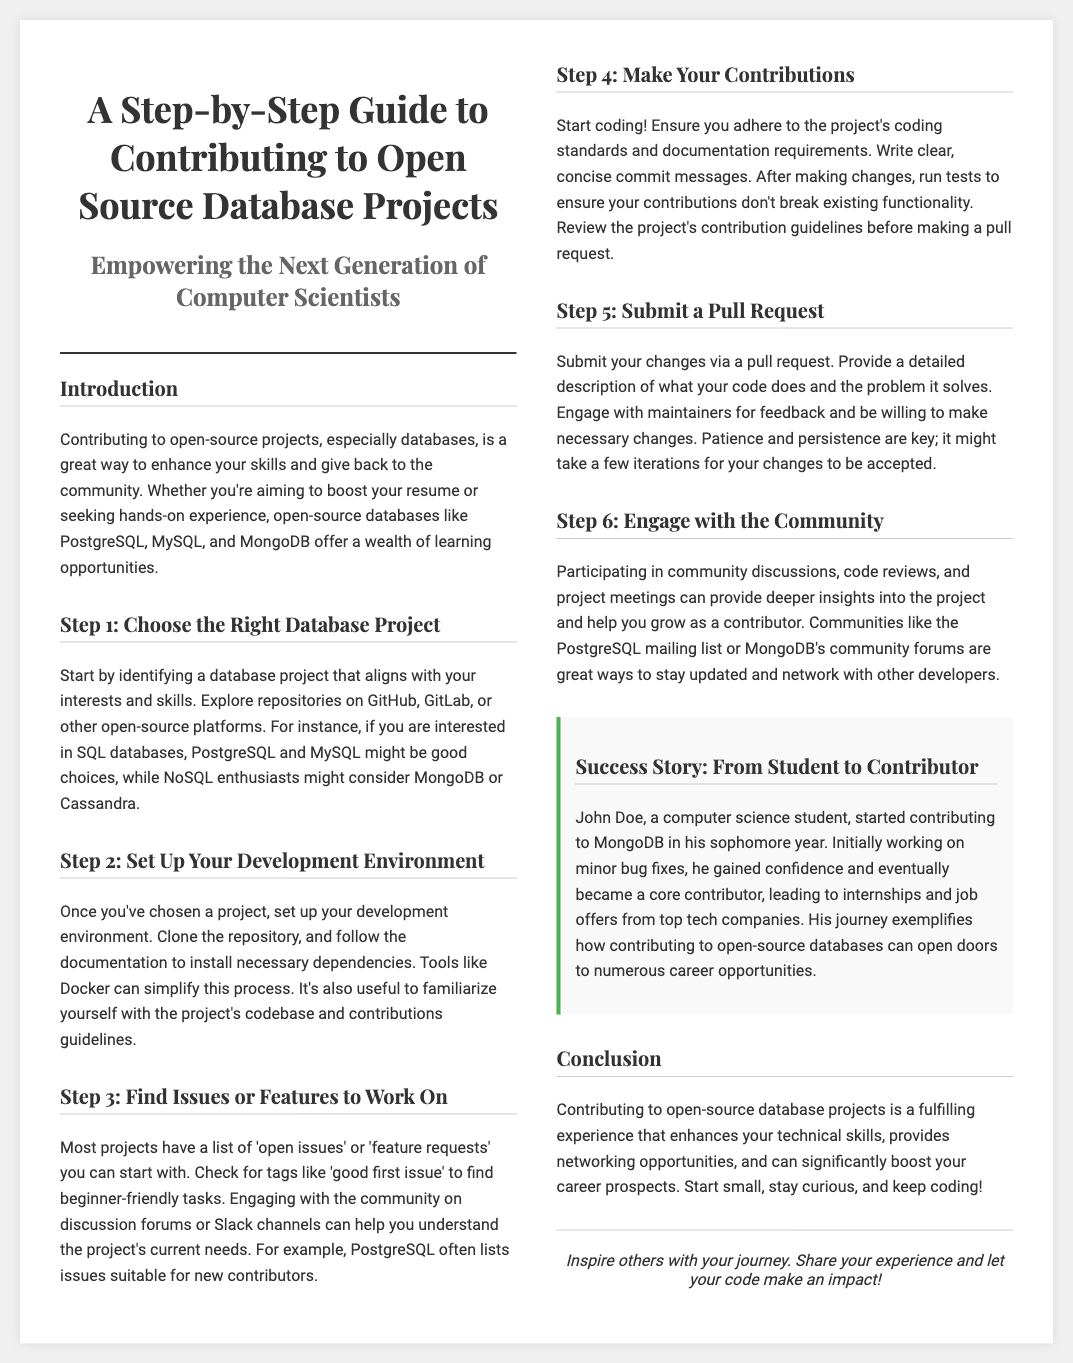What is the title of the guide? The title of the guide is prominently displayed at the top and provides clear information about its content.
Answer: A Step-by-Step Guide to Contributing to Open Source Database Projects Who is the target audience mentioned? The document indicates who the guide is intended for in the subtitle, suggesting a focus on a specific group.
Answer: The Next Generation of Computer Scientists What is Step 1 about? The content of the document explains what the first step involves for contributors, focusing on a key action.
Answer: Choose the Right Database Project Which databases are suggested for SQL enthusiasts? The guide lists specific examples of databases in relation to interests, providing concrete names.
Answer: PostgreSQL and MySQL What should code contributors ensure before making a pull request? The document highlights a crucial requirement for contributors when they submit their changes.
Answer: Adhere to the project's coding standards and documentation requirements What is a success story mentioned? The document provides an example that illustrates the potential outcomes of contributing, showcasing real experience.
Answer: John Doe, a computer science student How many steps are there in the guide? The overall structure of the document can be assessed to determine the total number of steps it outlines.
Answer: Six steps What is a suggested platform to explore repository options? The document mentions specific locations for contributors to find database projects, indicating popular choices.
Answer: GitHub and GitLab What kind of issues should new contributors look for? The document offers guidance on finding tasks that are suitable for beginners, aiding new contributors.
Answer: Good first issue 